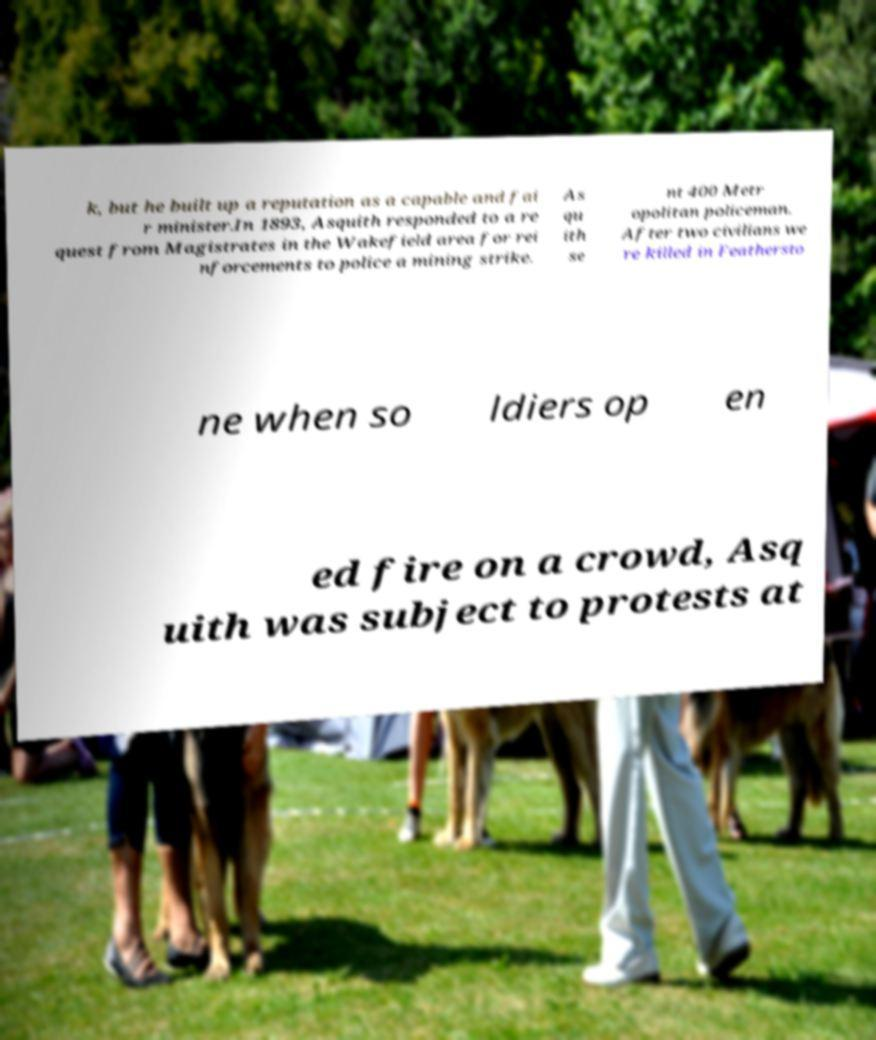Could you assist in decoding the text presented in this image and type it out clearly? k, but he built up a reputation as a capable and fai r minister.In 1893, Asquith responded to a re quest from Magistrates in the Wakefield area for rei nforcements to police a mining strike. As qu ith se nt 400 Metr opolitan policeman. After two civilians we re killed in Feathersto ne when so ldiers op en ed fire on a crowd, Asq uith was subject to protests at 